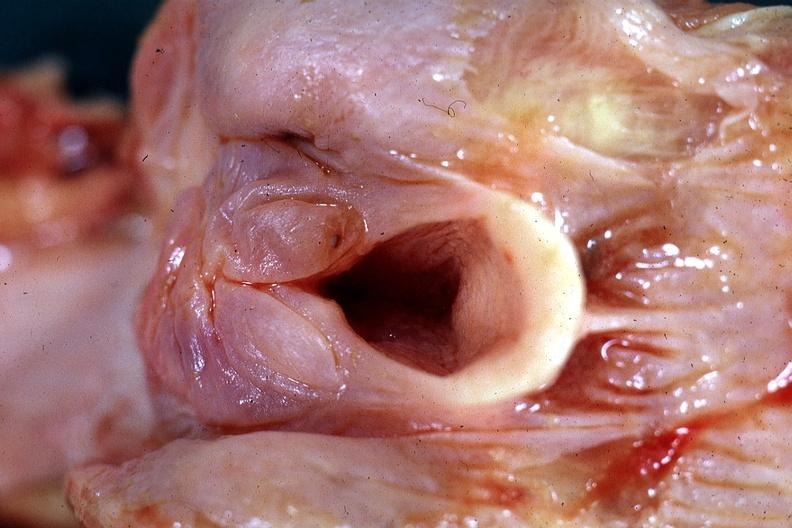s pharynx present?
Answer the question using a single word or phrase. Yes 